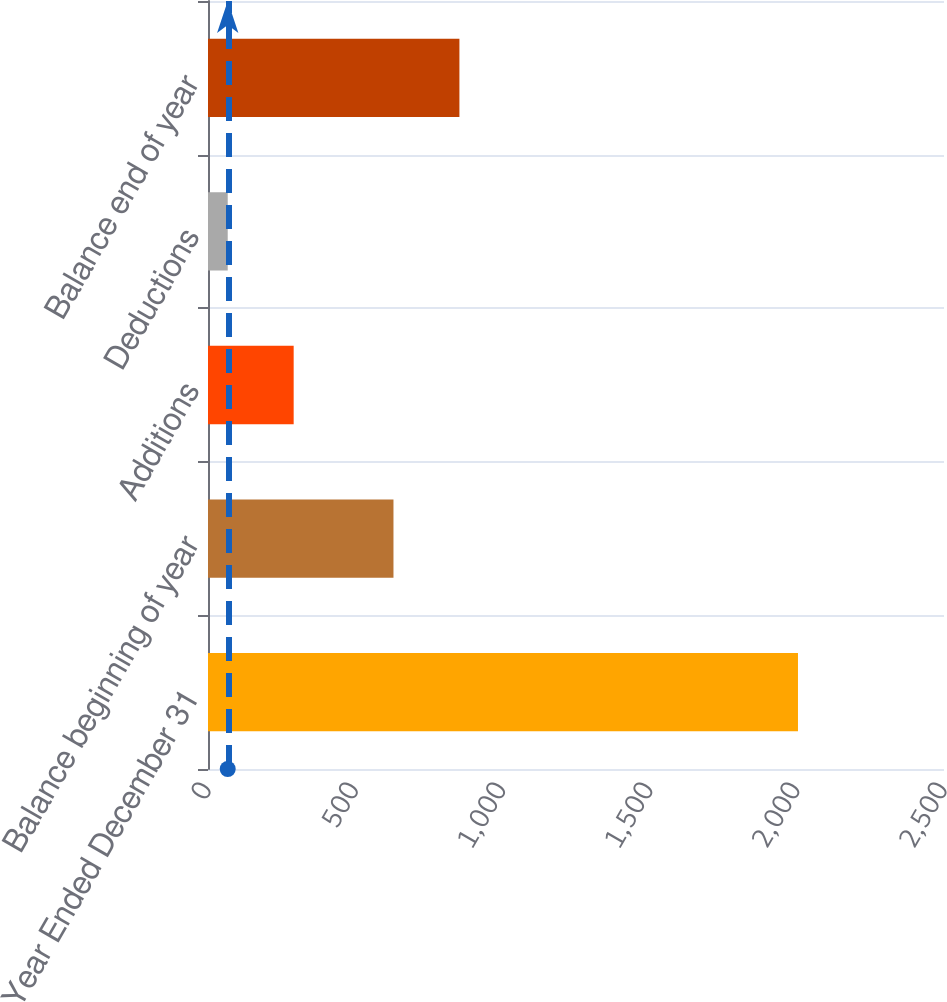Convert chart. <chart><loc_0><loc_0><loc_500><loc_500><bar_chart><fcel>Year Ended December 31<fcel>Balance beginning of year<fcel>Additions<fcel>Deductions<fcel>Balance end of year<nl><fcel>2004<fcel>630<fcel>291<fcel>67<fcel>854<nl></chart> 